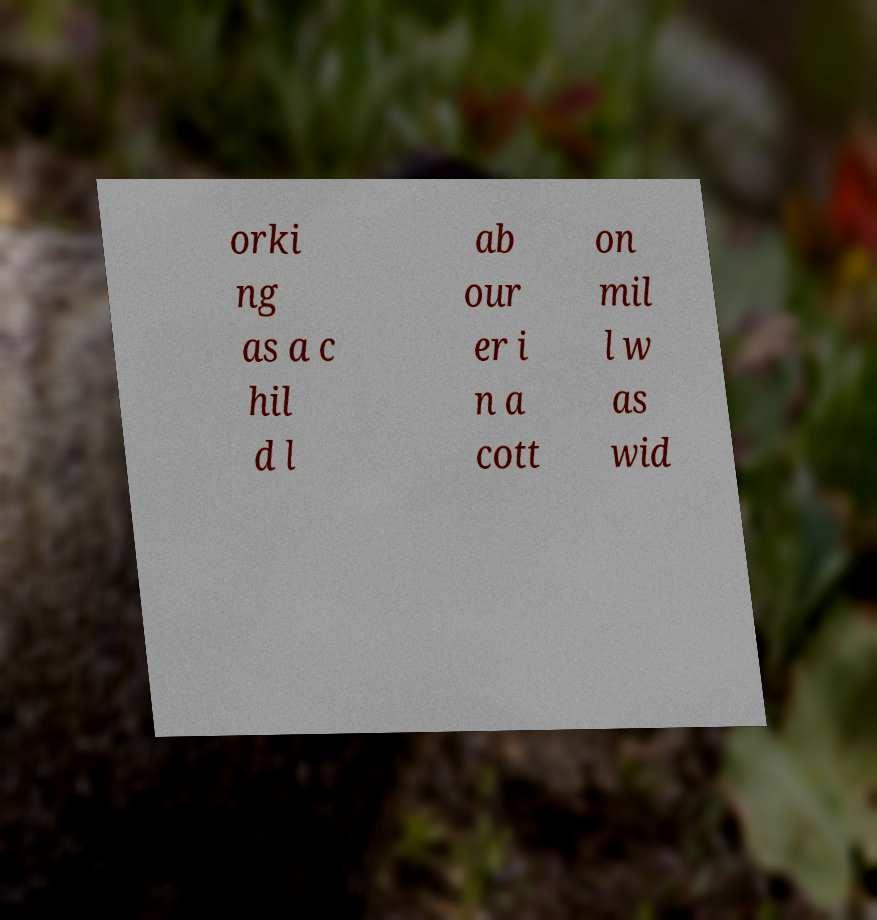Can you read and provide the text displayed in the image?This photo seems to have some interesting text. Can you extract and type it out for me? orki ng as a c hil d l ab our er i n a cott on mil l w as wid 